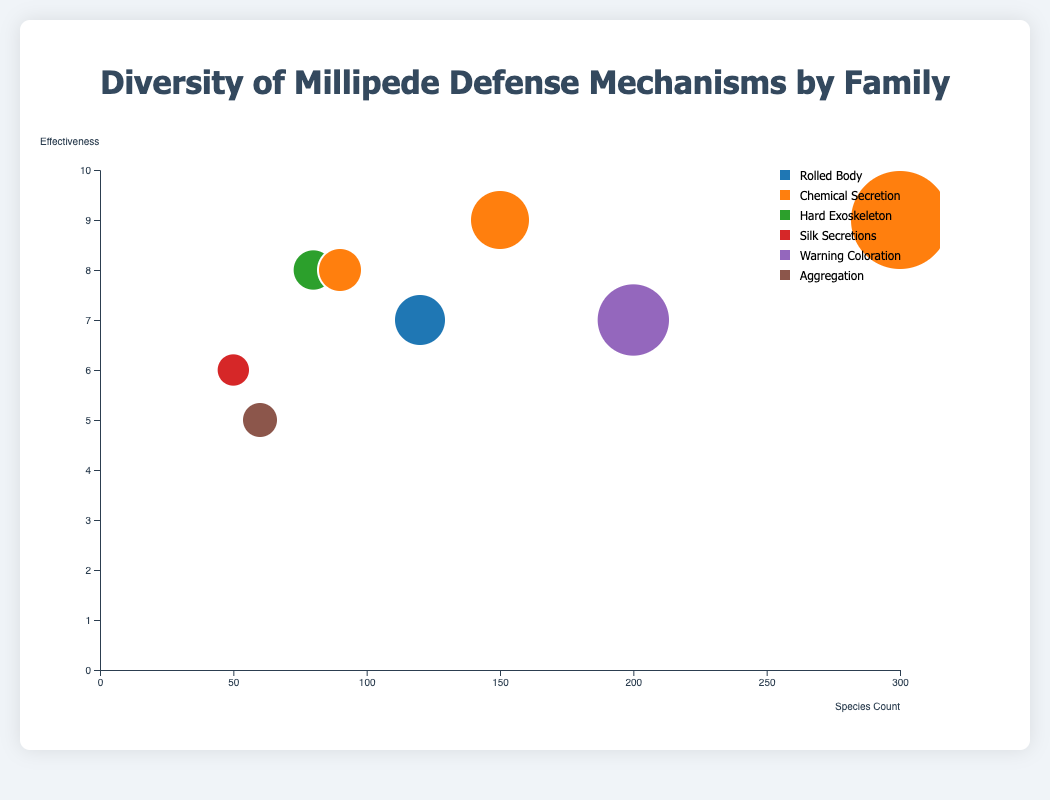What is the title of the chart? The title of the chart is typically displayed prominently at the top of the visualization to provide context and inform the viewer about the displayed data.
Answer: Diversity of Millipede Defense Mechanisms by Family How many families use "Chemical Secretion" as their defense mechanism? By observing the legend or the color-coded circles in the chart, we can identify how many distinct families use the same mechanism. Count the instances where the color corresponding to "Chemical Secretion" appears.
Answer: 3 Which family has the highest species count? We need to identify the bubble with the largest x-coordinate value, which represents the species count.
Answer: Paradoxosomatidae What is the effectiveness of the defense mechanism in the family "Julidae"? Locate the bubble for the family "Julidae," and read the y-coordinate value associated with it, which represents the effectiveness.
Answer: 5 Which family has the lowest effectiveness rating, and what is it? We need to find the bubble with the lowest y-coordinate value, as it represents the effectiveness.
Answer: Julidae, 5 Which defense mechanism appears in families with effectiveness ratings of 9? Identify the bubbles with a y-coordinate value of 9, and check the legend or color coding to see which defense mechanism those families use.
Answer: Chemical Secretion How do the species counts of "Polydesmidae" and "Sphaerotheriidae" compare? Compare the x-coordinate values of the bubbles for both families to determine which has a higher species count.
Answer: Polydesmidae has more species What is the average effectiveness rating for families using "Chemical Secretion"? Identify the y-coordinate values of all bubbles representing "Chemical Secretion," sum them up, and divide by the number of those families. (Effectiveness ratings: 9, 9, 8; (9+9+8)/3)
Answer: 8.67 Which family has more species, "Julidae" or "Spirobolidae?" Compare the x-coordinate values of the bubbles for both families to determine which one has a higher species count.
Answer: Spirobolidae How many children does the legend have? Count the number of entries in the legend, with each unique defense mechanism corresponding to one entry.
Answer: 6 